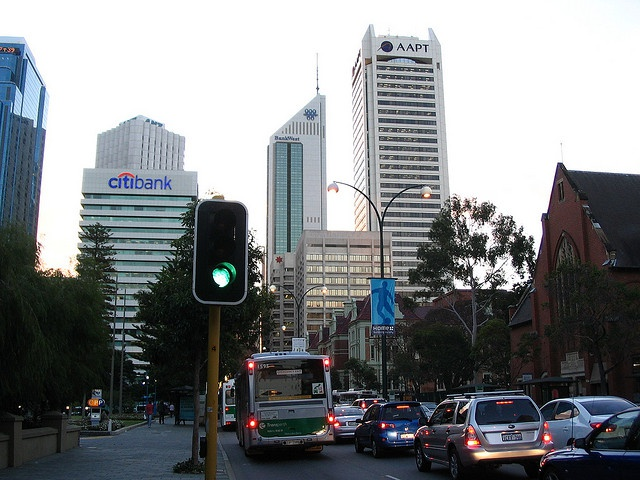Describe the objects in this image and their specific colors. I can see car in white, black, gray, and darkgray tones, bus in white, black, gray, maroon, and darkblue tones, traffic light in white, black, gray, and darkgray tones, car in white, black, gray, and blue tones, and car in white, black, navy, and gray tones in this image. 